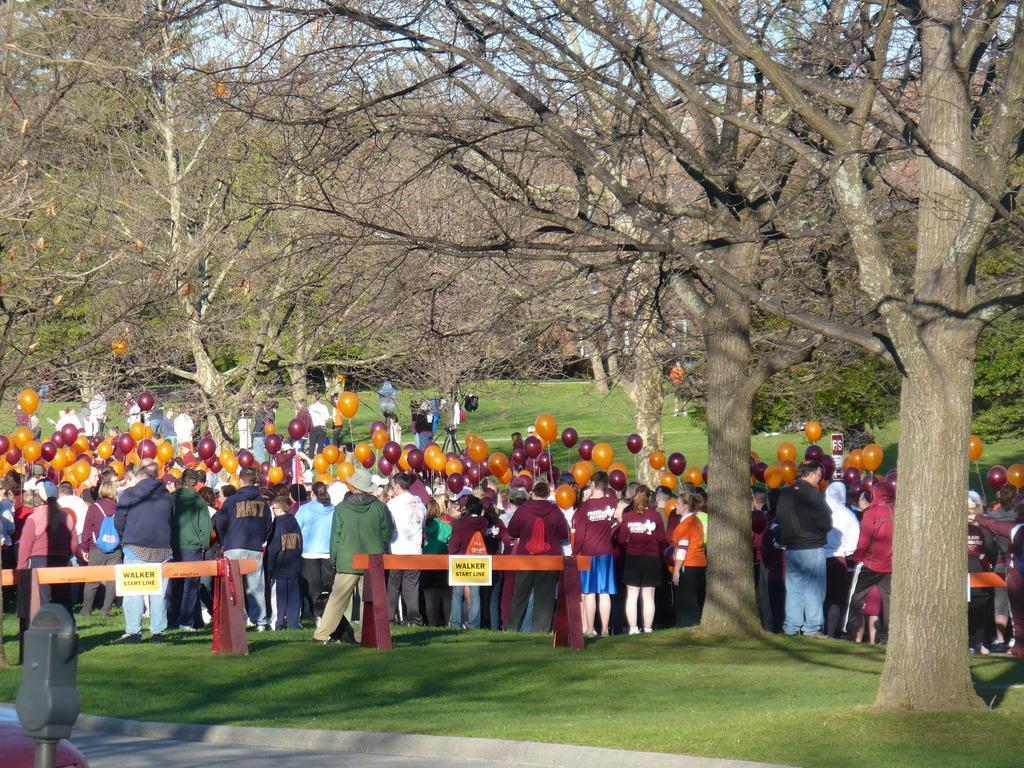Describe this image in one or two sentences. In this image we can see barriers. Behind the barriers, we can see so many people. They are holding balloons in their hands. In the middle of the image, we can see trees. At the top of the image, we can see the sky. At the bottom of the image, we can see grassy land and pavement. There is a metal object in the left bottom of the image. 